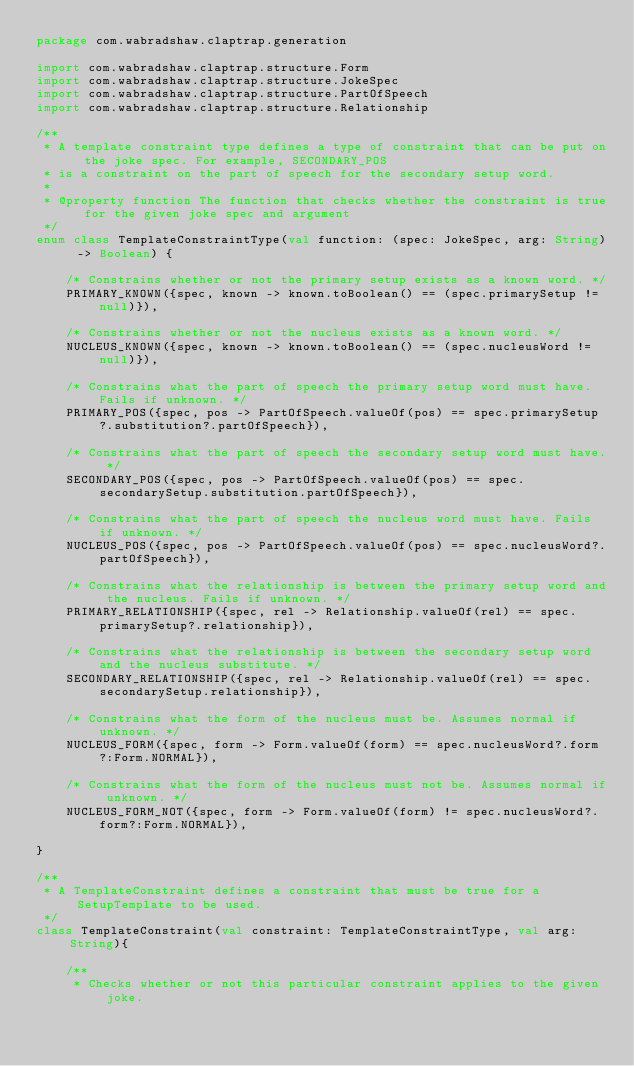<code> <loc_0><loc_0><loc_500><loc_500><_Kotlin_>package com.wabradshaw.claptrap.generation

import com.wabradshaw.claptrap.structure.Form
import com.wabradshaw.claptrap.structure.JokeSpec
import com.wabradshaw.claptrap.structure.PartOfSpeech
import com.wabradshaw.claptrap.structure.Relationship

/**
 * A template constraint type defines a type of constraint that can be put on the joke spec. For example, SECONDARY_POS
 * is a constraint on the part of speech for the secondary setup word.
 *
 * @property function The function that checks whether the constraint is true for the given joke spec and argument
 */
enum class TemplateConstraintType(val function: (spec: JokeSpec, arg: String) -> Boolean) {

    /* Constrains whether or not the primary setup exists as a known word. */
    PRIMARY_KNOWN({spec, known -> known.toBoolean() == (spec.primarySetup != null)}),

    /* Constrains whether or not the nucleus exists as a known word. */
    NUCLEUS_KNOWN({spec, known -> known.toBoolean() == (spec.nucleusWord != null)}),

    /* Constrains what the part of speech the primary setup word must have. Fails if unknown. */
    PRIMARY_POS({spec, pos -> PartOfSpeech.valueOf(pos) == spec.primarySetup?.substitution?.partOfSpeech}),

    /* Constrains what the part of speech the secondary setup word must have. */
    SECONDARY_POS({spec, pos -> PartOfSpeech.valueOf(pos) == spec.secondarySetup.substitution.partOfSpeech}),

    /* Constrains what the part of speech the nucleus word must have. Fails if unknown. */
    NUCLEUS_POS({spec, pos -> PartOfSpeech.valueOf(pos) == spec.nucleusWord?.partOfSpeech}),

    /* Constrains what the relationship is between the primary setup word and the nucleus. Fails if unknown. */
    PRIMARY_RELATIONSHIP({spec, rel -> Relationship.valueOf(rel) == spec.primarySetup?.relationship}),

    /* Constrains what the relationship is between the secondary setup word and the nucleus substitute. */
    SECONDARY_RELATIONSHIP({spec, rel -> Relationship.valueOf(rel) == spec.secondarySetup.relationship}),

    /* Constrains what the form of the nucleus must be. Assumes normal if unknown. */
    NUCLEUS_FORM({spec, form -> Form.valueOf(form) == spec.nucleusWord?.form?:Form.NORMAL}),

    /* Constrains what the form of the nucleus must not be. Assumes normal if unknown. */
    NUCLEUS_FORM_NOT({spec, form -> Form.valueOf(form) != spec.nucleusWord?.form?:Form.NORMAL}),

}

/**
 * A TemplateConstraint defines a constraint that must be true for a SetupTemplate to be used.
 */
class TemplateConstraint(val constraint: TemplateConstraintType, val arg: String){

    /**
     * Checks whether or not this particular constraint applies to the given joke.</code> 